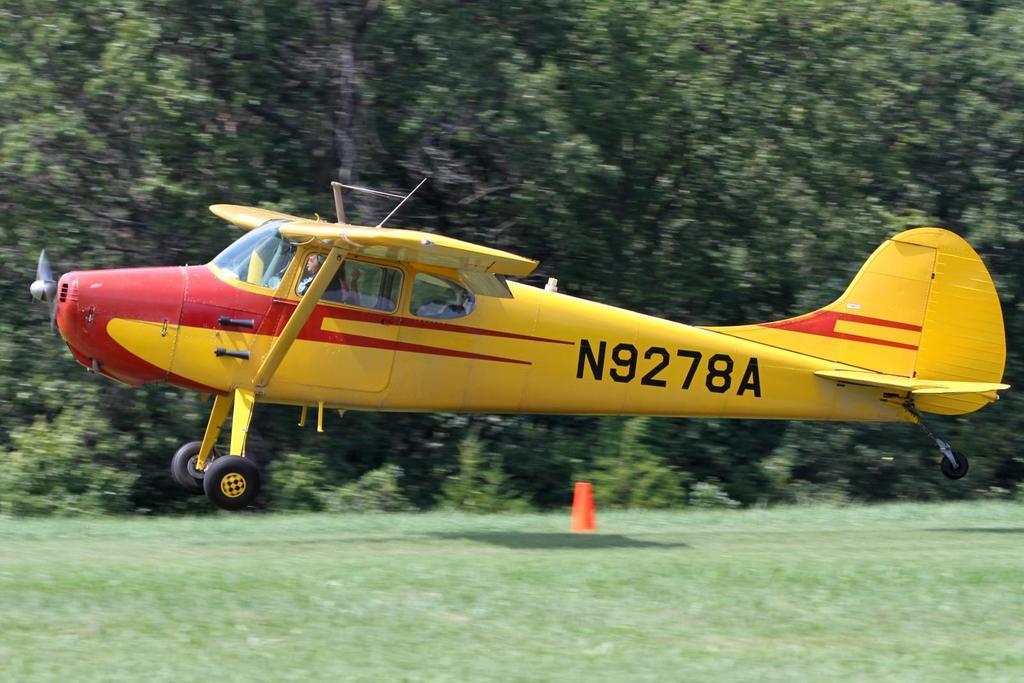Can you describe this image briefly? In this picture I can observe yellow color airplane. In the background there are trees. 